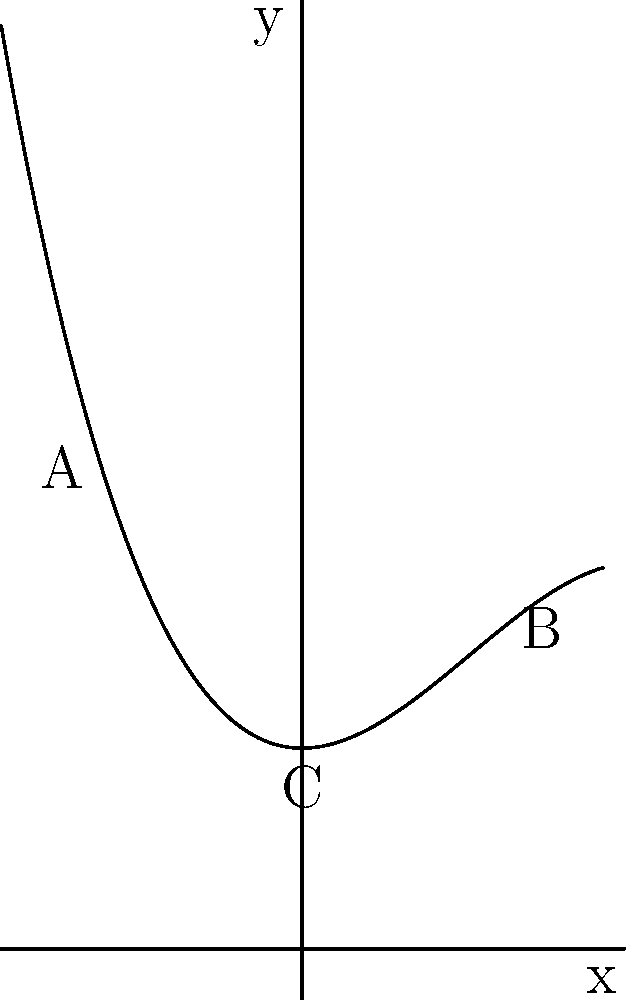The neckline of a new soccer jersey design is modeled by the polynomial function $f(x) = -0.1x^3 + 0.5x^2 + 2$, where $x$ is measured in inches from the center of the neckline and $f(x)$ represents the height of the neckline in inches. What is the total width of the neckline opening from point A to point B, rounded to the nearest inch? To find the width of the neckline opening, we need to determine the x-coordinates of points A and B, which represent the edges of the neckline.

1) The neckline is symmetrical, so we can find one x-coordinate and double it for the total width.

2) By observation, points A and B appear to be at x = -2 and x = 2 respectively.

3) To verify, we can check if f(-2) = f(2):
   
   $f(-2) = -0.1(-2)^3 + 0.5(-2)^2 + 2$
          $= -0.1(-8) + 0.5(4) + 2$
          $= 0.8 + 2 + 2 = 4.8$

   $f(2) = -0.1(2)^3 + 0.5(2)^2 + 2$
         $= -0.1(8) + 0.5(4) + 2$
         $= -0.8 + 2 + 2 = 4.8$

4) Since f(-2) = f(2), we confirm that these are the correct x-coordinates.

5) The total width is the distance between these two x-coordinates:
   Width = 2 - (-2) = 4 inches

Therefore, the total width of the neckline opening is 4 inches.
Answer: 4 inches 